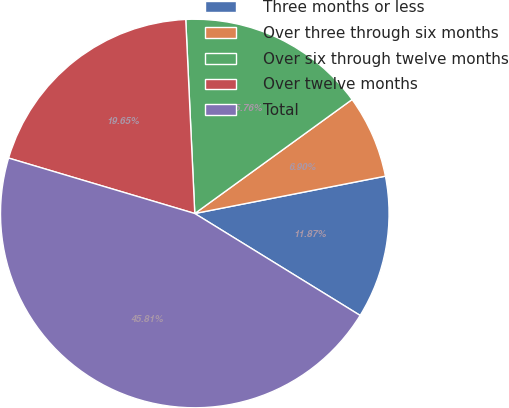Convert chart. <chart><loc_0><loc_0><loc_500><loc_500><pie_chart><fcel>Three months or less<fcel>Over three through six months<fcel>Over six through twelve months<fcel>Over twelve months<fcel>Total<nl><fcel>11.87%<fcel>6.9%<fcel>15.76%<fcel>19.65%<fcel>45.81%<nl></chart> 